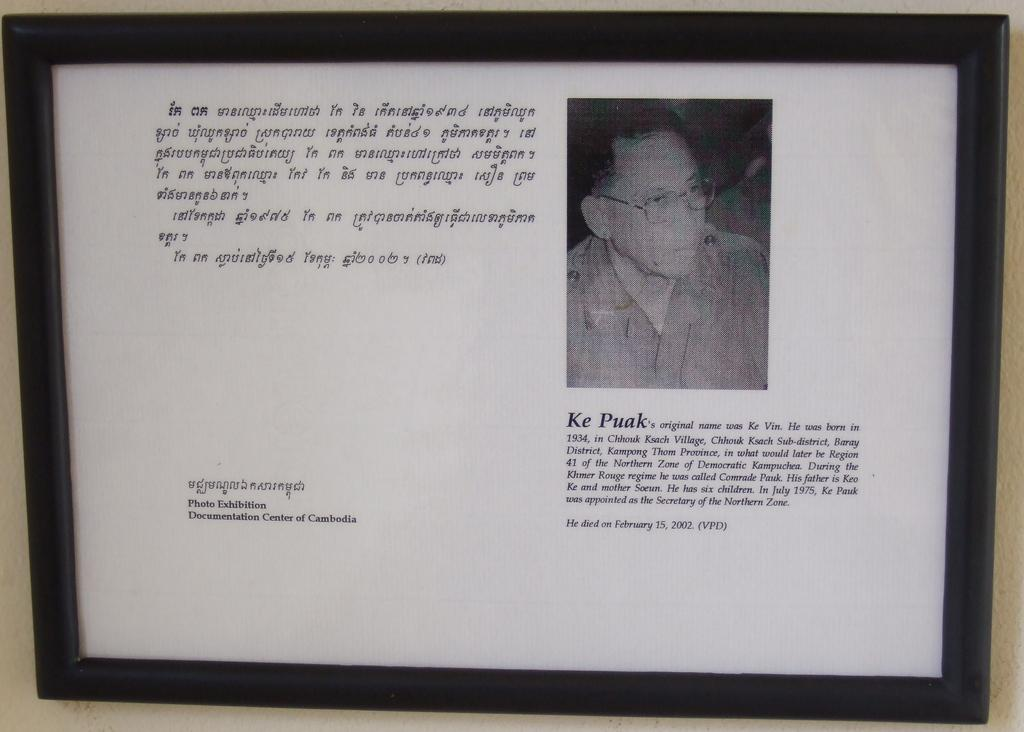<image>
Relay a brief, clear account of the picture shown. A photo of Ke Puak along with biographical information in a black frame. 